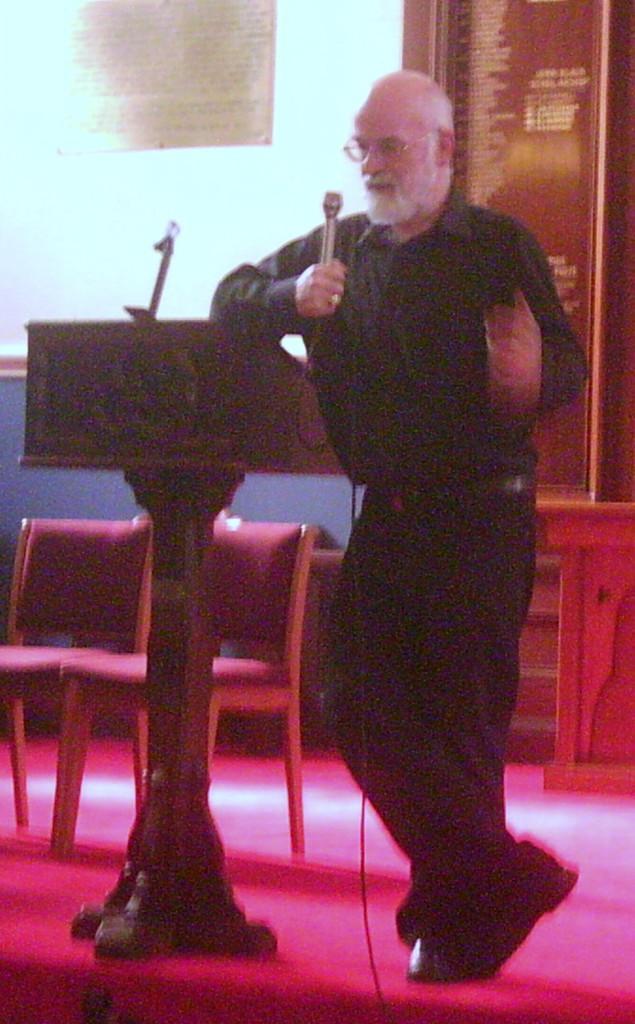Describe this image in one or two sentences. In this image I can see a man is standing and holding a microphone beside a podium. I can also see there are few chairs on the stage. 